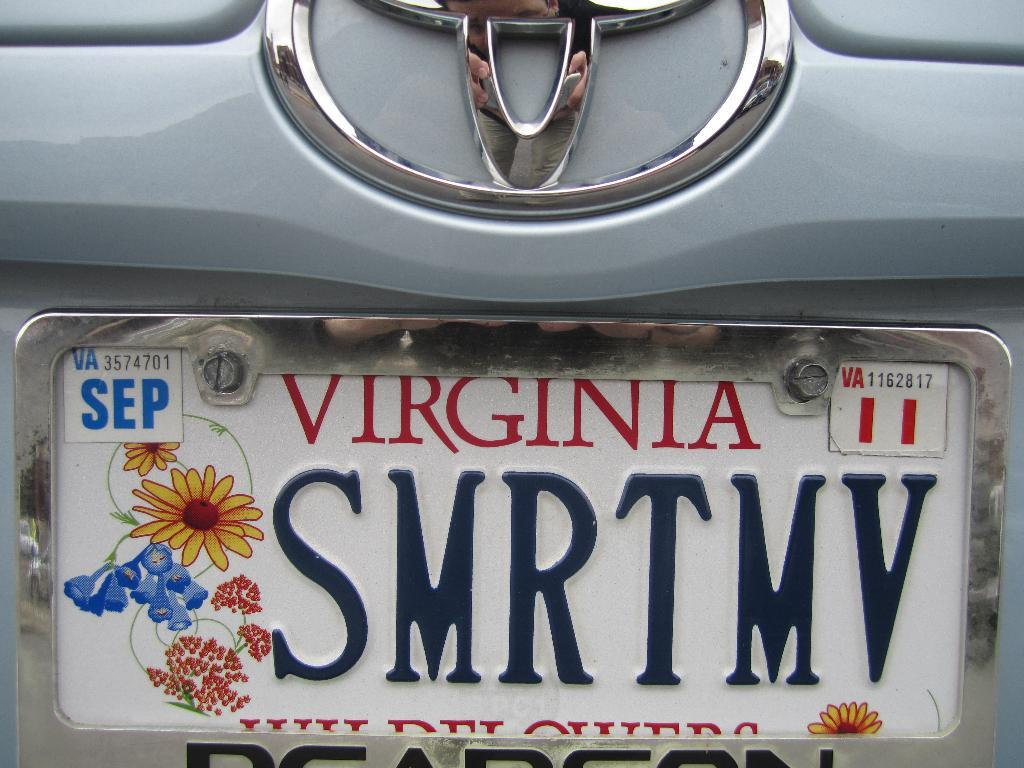<image>
Share a concise interpretation of the image provided. A personalized license plate would say "smart move" if it contained the correct vowels. 